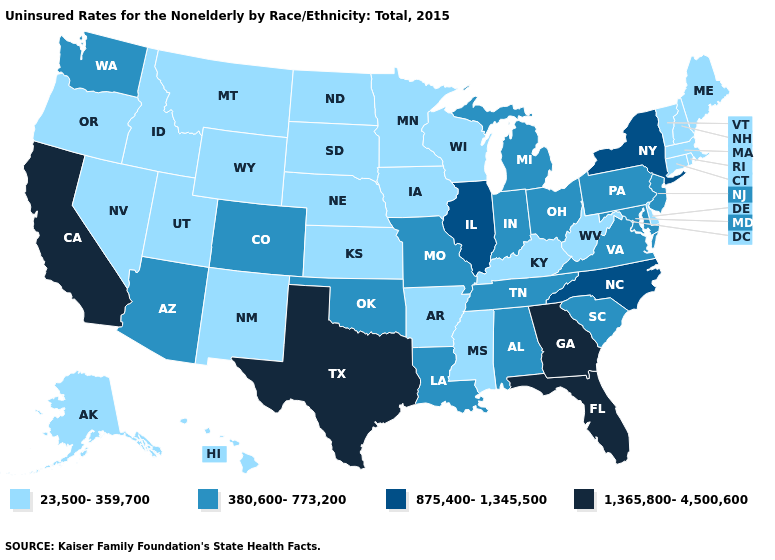What is the lowest value in the USA?
Short answer required. 23,500-359,700. What is the value of New Hampshire?
Concise answer only. 23,500-359,700. Does Georgia have the highest value in the USA?
Answer briefly. Yes. Among the states that border Tennessee , which have the lowest value?
Short answer required. Arkansas, Kentucky, Mississippi. Does the first symbol in the legend represent the smallest category?
Write a very short answer. Yes. What is the value of Texas?
Give a very brief answer. 1,365,800-4,500,600. Name the states that have a value in the range 380,600-773,200?
Keep it brief. Alabama, Arizona, Colorado, Indiana, Louisiana, Maryland, Michigan, Missouri, New Jersey, Ohio, Oklahoma, Pennsylvania, South Carolina, Tennessee, Virginia, Washington. Does New York have the lowest value in the Northeast?
Concise answer only. No. Among the states that border Texas , does Arkansas have the highest value?
Answer briefly. No. Does New Jersey have a lower value than Florida?
Keep it brief. Yes. Among the states that border Michigan , does Wisconsin have the lowest value?
Short answer required. Yes. What is the lowest value in the USA?
Keep it brief. 23,500-359,700. What is the highest value in the South ?
Short answer required. 1,365,800-4,500,600. Name the states that have a value in the range 875,400-1,345,500?
Answer briefly. Illinois, New York, North Carolina. Which states have the lowest value in the West?
Be succinct. Alaska, Hawaii, Idaho, Montana, Nevada, New Mexico, Oregon, Utah, Wyoming. 